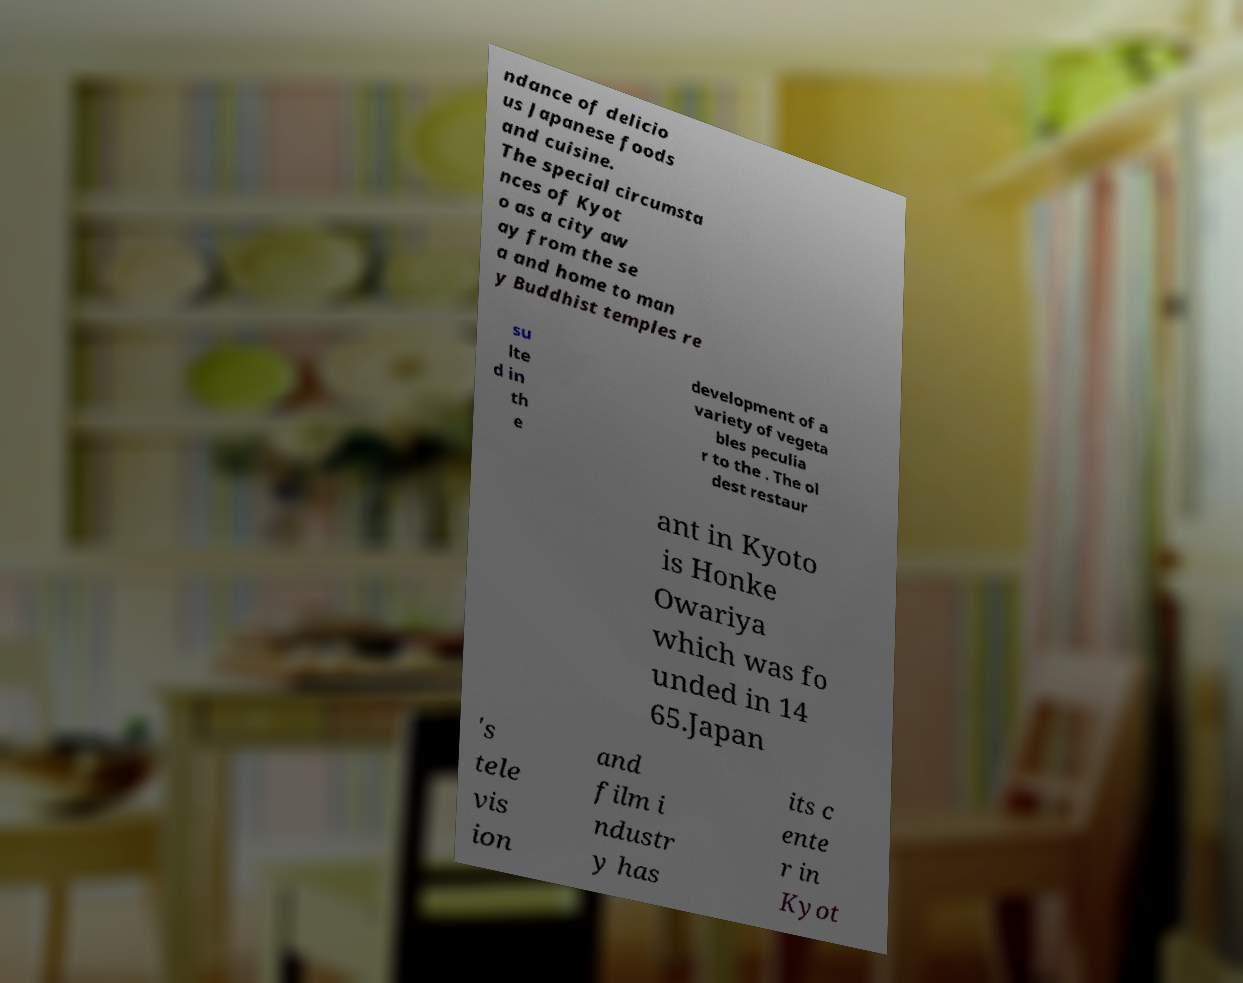Could you assist in decoding the text presented in this image and type it out clearly? ndance of delicio us Japanese foods and cuisine. The special circumsta nces of Kyot o as a city aw ay from the se a and home to man y Buddhist temples re su lte d in th e development of a variety of vegeta bles peculia r to the . The ol dest restaur ant in Kyoto is Honke Owariya which was fo unded in 14 65.Japan 's tele vis ion and film i ndustr y has its c ente r in Kyot 